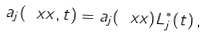Convert formula to latex. <formula><loc_0><loc_0><loc_500><loc_500>a _ { j } ( \ x x , t ) = a _ { j } ( \ x x ) L ^ { \ast } _ { j } ( t ) \, ,</formula> 